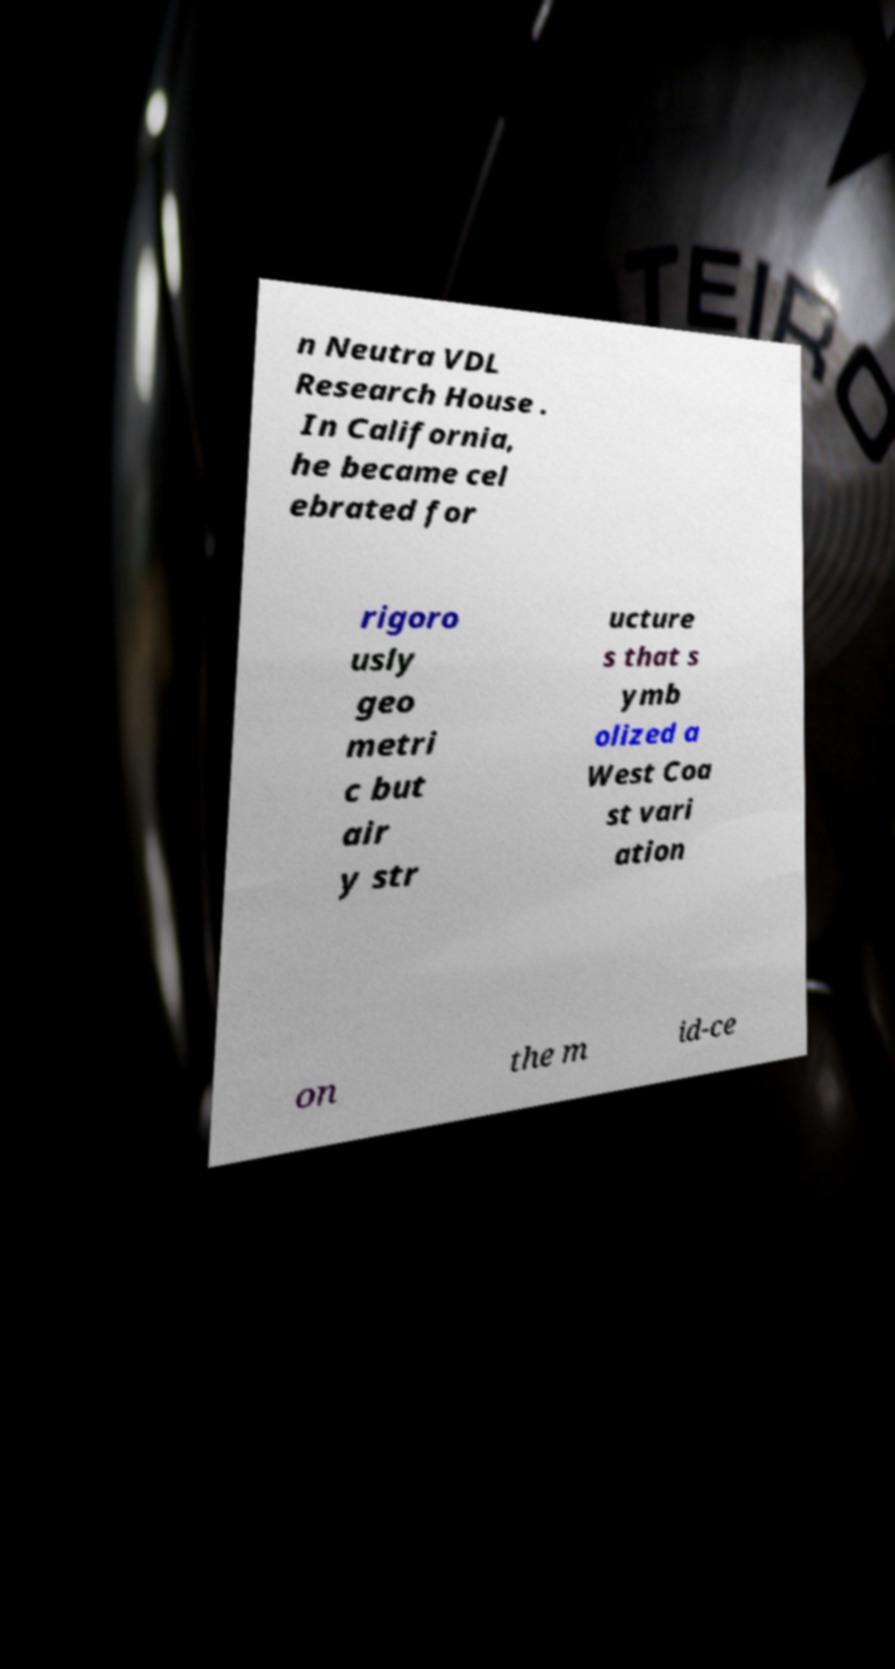Could you extract and type out the text from this image? n Neutra VDL Research House . In California, he became cel ebrated for rigoro usly geo metri c but air y str ucture s that s ymb olized a West Coa st vari ation on the m id-ce 